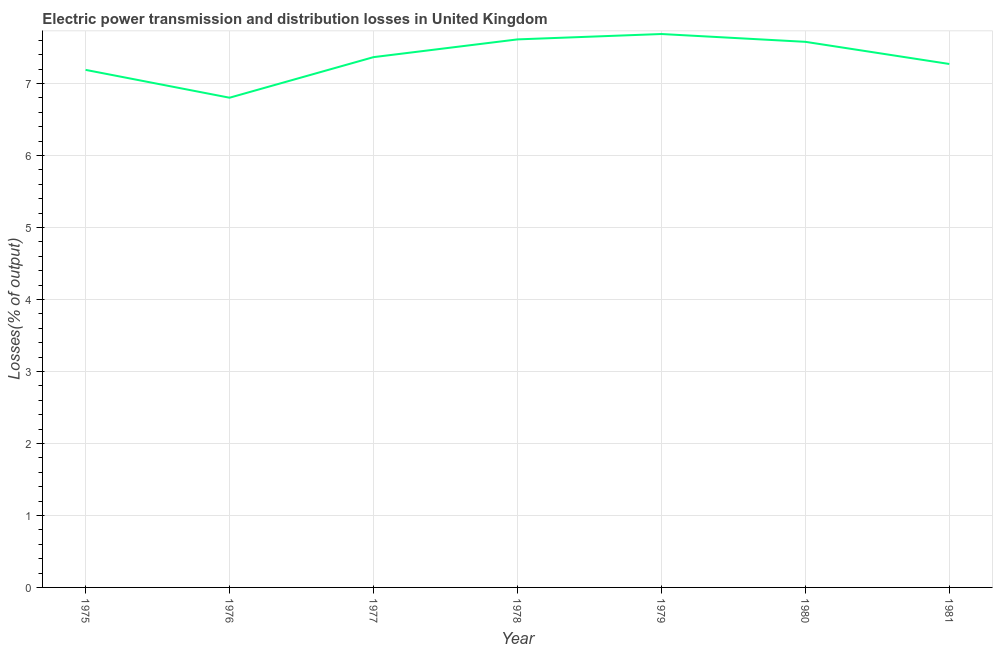What is the electric power transmission and distribution losses in 1981?
Your answer should be very brief. 7.27. Across all years, what is the maximum electric power transmission and distribution losses?
Provide a short and direct response. 7.69. Across all years, what is the minimum electric power transmission and distribution losses?
Offer a very short reply. 6.8. In which year was the electric power transmission and distribution losses maximum?
Offer a very short reply. 1979. In which year was the electric power transmission and distribution losses minimum?
Provide a succinct answer. 1976. What is the sum of the electric power transmission and distribution losses?
Keep it short and to the point. 51.52. What is the difference between the electric power transmission and distribution losses in 1975 and 1981?
Keep it short and to the point. -0.08. What is the average electric power transmission and distribution losses per year?
Provide a succinct answer. 7.36. What is the median electric power transmission and distribution losses?
Your response must be concise. 7.37. What is the ratio of the electric power transmission and distribution losses in 1975 to that in 1979?
Your response must be concise. 0.94. What is the difference between the highest and the second highest electric power transmission and distribution losses?
Give a very brief answer. 0.07. Is the sum of the electric power transmission and distribution losses in 1976 and 1980 greater than the maximum electric power transmission and distribution losses across all years?
Provide a succinct answer. Yes. What is the difference between the highest and the lowest electric power transmission and distribution losses?
Offer a very short reply. 0.89. In how many years, is the electric power transmission and distribution losses greater than the average electric power transmission and distribution losses taken over all years?
Make the answer very short. 4. Does the electric power transmission and distribution losses monotonically increase over the years?
Ensure brevity in your answer.  No. How many lines are there?
Your response must be concise. 1. Does the graph contain grids?
Ensure brevity in your answer.  Yes. What is the title of the graph?
Provide a succinct answer. Electric power transmission and distribution losses in United Kingdom. What is the label or title of the X-axis?
Give a very brief answer. Year. What is the label or title of the Y-axis?
Your response must be concise. Losses(% of output). What is the Losses(% of output) in 1975?
Your answer should be very brief. 7.19. What is the Losses(% of output) in 1976?
Offer a terse response. 6.8. What is the Losses(% of output) of 1977?
Your answer should be compact. 7.37. What is the Losses(% of output) in 1978?
Provide a succinct answer. 7.61. What is the Losses(% of output) in 1979?
Your response must be concise. 7.69. What is the Losses(% of output) of 1980?
Your answer should be very brief. 7.58. What is the Losses(% of output) of 1981?
Your answer should be very brief. 7.27. What is the difference between the Losses(% of output) in 1975 and 1976?
Your answer should be very brief. 0.39. What is the difference between the Losses(% of output) in 1975 and 1977?
Give a very brief answer. -0.18. What is the difference between the Losses(% of output) in 1975 and 1978?
Provide a succinct answer. -0.42. What is the difference between the Losses(% of output) in 1975 and 1979?
Your response must be concise. -0.5. What is the difference between the Losses(% of output) in 1975 and 1980?
Provide a short and direct response. -0.39. What is the difference between the Losses(% of output) in 1975 and 1981?
Ensure brevity in your answer.  -0.08. What is the difference between the Losses(% of output) in 1976 and 1977?
Give a very brief answer. -0.56. What is the difference between the Losses(% of output) in 1976 and 1978?
Give a very brief answer. -0.81. What is the difference between the Losses(% of output) in 1976 and 1979?
Ensure brevity in your answer.  -0.89. What is the difference between the Losses(% of output) in 1976 and 1980?
Keep it short and to the point. -0.78. What is the difference between the Losses(% of output) in 1976 and 1981?
Your answer should be compact. -0.47. What is the difference between the Losses(% of output) in 1977 and 1978?
Ensure brevity in your answer.  -0.25. What is the difference between the Losses(% of output) in 1977 and 1979?
Your answer should be very brief. -0.32. What is the difference between the Losses(% of output) in 1977 and 1980?
Your answer should be compact. -0.21. What is the difference between the Losses(% of output) in 1977 and 1981?
Provide a short and direct response. 0.1. What is the difference between the Losses(% of output) in 1978 and 1979?
Give a very brief answer. -0.07. What is the difference between the Losses(% of output) in 1978 and 1980?
Your response must be concise. 0.03. What is the difference between the Losses(% of output) in 1978 and 1981?
Provide a short and direct response. 0.34. What is the difference between the Losses(% of output) in 1979 and 1980?
Provide a short and direct response. 0.11. What is the difference between the Losses(% of output) in 1979 and 1981?
Ensure brevity in your answer.  0.42. What is the difference between the Losses(% of output) in 1980 and 1981?
Your answer should be very brief. 0.31. What is the ratio of the Losses(% of output) in 1975 to that in 1976?
Provide a succinct answer. 1.06. What is the ratio of the Losses(% of output) in 1975 to that in 1977?
Ensure brevity in your answer.  0.98. What is the ratio of the Losses(% of output) in 1975 to that in 1978?
Make the answer very short. 0.94. What is the ratio of the Losses(% of output) in 1975 to that in 1979?
Provide a succinct answer. 0.94. What is the ratio of the Losses(% of output) in 1975 to that in 1980?
Ensure brevity in your answer.  0.95. What is the ratio of the Losses(% of output) in 1975 to that in 1981?
Your answer should be very brief. 0.99. What is the ratio of the Losses(% of output) in 1976 to that in 1977?
Make the answer very short. 0.92. What is the ratio of the Losses(% of output) in 1976 to that in 1978?
Your response must be concise. 0.89. What is the ratio of the Losses(% of output) in 1976 to that in 1979?
Offer a terse response. 0.89. What is the ratio of the Losses(% of output) in 1976 to that in 1980?
Provide a short and direct response. 0.9. What is the ratio of the Losses(% of output) in 1976 to that in 1981?
Offer a terse response. 0.94. What is the ratio of the Losses(% of output) in 1977 to that in 1979?
Offer a terse response. 0.96. What is the ratio of the Losses(% of output) in 1978 to that in 1979?
Your answer should be compact. 0.99. What is the ratio of the Losses(% of output) in 1978 to that in 1981?
Your answer should be compact. 1.05. What is the ratio of the Losses(% of output) in 1979 to that in 1980?
Keep it short and to the point. 1.01. What is the ratio of the Losses(% of output) in 1979 to that in 1981?
Provide a succinct answer. 1.06. What is the ratio of the Losses(% of output) in 1980 to that in 1981?
Your response must be concise. 1.04. 